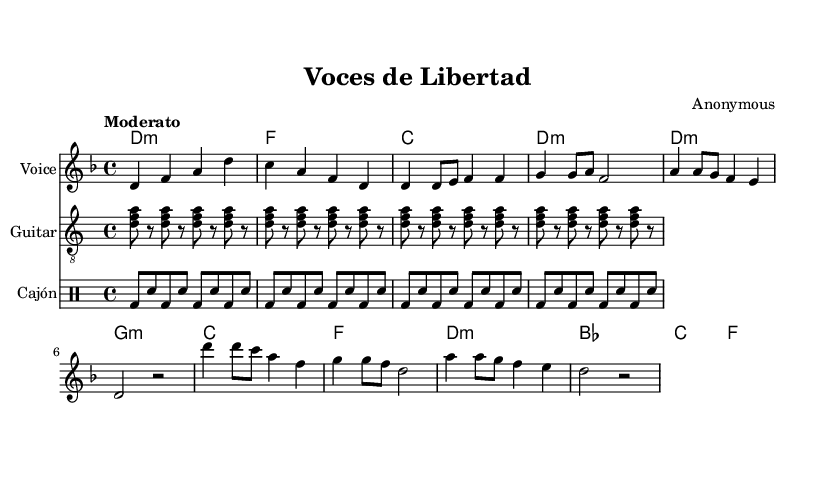What is the key signature of this music? The key signature indicates two flats, which is typical for D minor as it is linked to its relative major, F major.
Answer: D minor What is the time signature of this music? The time signature is indicated at the beginning of the score, showing four beats in a measure, which corresponds to the common 4/4 time signature.
Answer: 4/4 What is the tempo marking for this piece? The tempo marking in the score states "Moderato," suggesting a moderate speed for the performance of the music.
Answer: Moderato How many measures are in the verse section? By counting the segments of the melody labeled as the verse, there are four measures in this section before reaching the chorus.
Answer: 4 In what language are the lyrics of this song written? The lyrics are presented in the lyrics section, which is in Spanish, evident from the words used throughout the song.
Answer: Spanish What type of percussion is indicated in the score? The score includes a specific drum staff for the Cajón, which is a traditional percussion instrument common in Latin American music, as noted next to the staff.
Answer: Cajón Which section of the song introduces a call for liberty? The chorus section, highlighted in the lyrics, explicitly expresses a call for liberty through its repeated phrase, making it distinctive within the song.
Answer: Chorus 